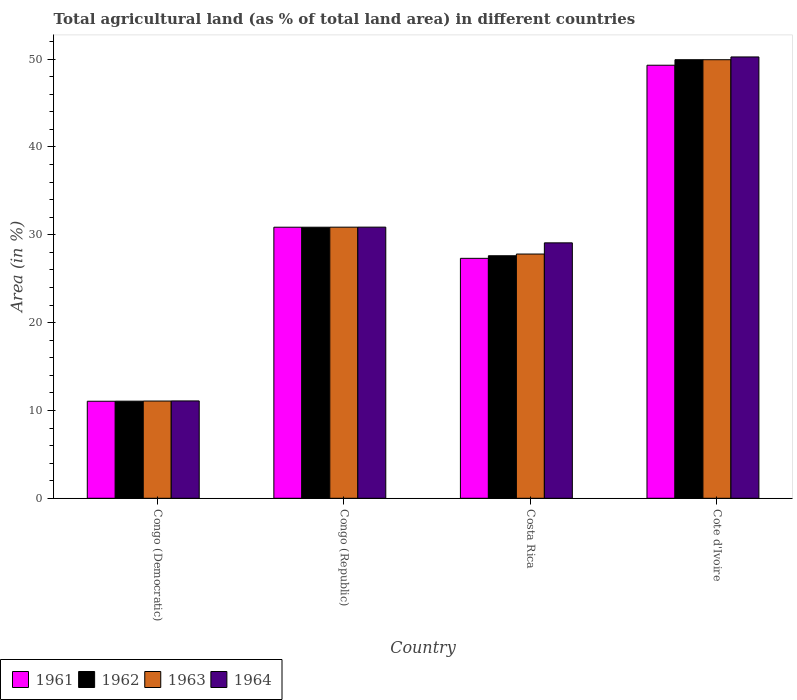How many different coloured bars are there?
Your answer should be compact. 4. How many groups of bars are there?
Your response must be concise. 4. Are the number of bars per tick equal to the number of legend labels?
Offer a terse response. Yes. Are the number of bars on each tick of the X-axis equal?
Keep it short and to the point. Yes. How many bars are there on the 3rd tick from the left?
Ensure brevity in your answer.  4. What is the label of the 4th group of bars from the left?
Offer a very short reply. Cote d'Ivoire. What is the percentage of agricultural land in 1963 in Congo (Democratic)?
Give a very brief answer. 11.07. Across all countries, what is the maximum percentage of agricultural land in 1963?
Make the answer very short. 49.94. Across all countries, what is the minimum percentage of agricultural land in 1963?
Provide a succinct answer. 11.07. In which country was the percentage of agricultural land in 1963 maximum?
Offer a terse response. Cote d'Ivoire. In which country was the percentage of agricultural land in 1964 minimum?
Make the answer very short. Congo (Democratic). What is the total percentage of agricultural land in 1962 in the graph?
Keep it short and to the point. 119.47. What is the difference between the percentage of agricultural land in 1961 in Costa Rica and that in Cote d'Ivoire?
Offer a terse response. -21.99. What is the difference between the percentage of agricultural land in 1961 in Congo (Democratic) and the percentage of agricultural land in 1964 in Congo (Republic)?
Your response must be concise. -19.82. What is the average percentage of agricultural land in 1963 per country?
Your answer should be compact. 29.92. What is the ratio of the percentage of agricultural land in 1962 in Congo (Democratic) to that in Costa Rica?
Ensure brevity in your answer.  0.4. What is the difference between the highest and the second highest percentage of agricultural land in 1964?
Offer a terse response. 21.17. What is the difference between the highest and the lowest percentage of agricultural land in 1962?
Make the answer very short. 38.88. Is it the case that in every country, the sum of the percentage of agricultural land in 1963 and percentage of agricultural land in 1964 is greater than the sum of percentage of agricultural land in 1961 and percentage of agricultural land in 1962?
Make the answer very short. No. What does the 2nd bar from the left in Congo (Republic) represents?
Give a very brief answer. 1962. What does the 3rd bar from the right in Congo (Democratic) represents?
Ensure brevity in your answer.  1962. Is it the case that in every country, the sum of the percentage of agricultural land in 1964 and percentage of agricultural land in 1961 is greater than the percentage of agricultural land in 1962?
Give a very brief answer. Yes. What is the difference between two consecutive major ticks on the Y-axis?
Your answer should be compact. 10. Does the graph contain any zero values?
Make the answer very short. No. Does the graph contain grids?
Make the answer very short. No. How many legend labels are there?
Keep it short and to the point. 4. How are the legend labels stacked?
Your response must be concise. Horizontal. What is the title of the graph?
Provide a short and direct response. Total agricultural land (as % of total land area) in different countries. What is the label or title of the Y-axis?
Give a very brief answer. Area (in %). What is the Area (in %) in 1961 in Congo (Democratic)?
Make the answer very short. 11.05. What is the Area (in %) of 1962 in Congo (Democratic)?
Provide a short and direct response. 11.06. What is the Area (in %) in 1963 in Congo (Democratic)?
Provide a short and direct response. 11.07. What is the Area (in %) in 1964 in Congo (Democratic)?
Offer a terse response. 11.08. What is the Area (in %) in 1961 in Congo (Republic)?
Make the answer very short. 30.86. What is the Area (in %) of 1962 in Congo (Republic)?
Offer a terse response. 30.86. What is the Area (in %) in 1963 in Congo (Republic)?
Keep it short and to the point. 30.87. What is the Area (in %) in 1964 in Congo (Republic)?
Provide a succinct answer. 30.87. What is the Area (in %) of 1961 in Costa Rica?
Offer a very short reply. 27.32. What is the Area (in %) of 1962 in Costa Rica?
Your answer should be compact. 27.61. What is the Area (in %) in 1963 in Costa Rica?
Make the answer very short. 27.81. What is the Area (in %) of 1964 in Costa Rica?
Offer a terse response. 29.08. What is the Area (in %) in 1961 in Cote d'Ivoire?
Your answer should be very brief. 49.31. What is the Area (in %) of 1962 in Cote d'Ivoire?
Offer a terse response. 49.94. What is the Area (in %) of 1963 in Cote d'Ivoire?
Your answer should be compact. 49.94. What is the Area (in %) in 1964 in Cote d'Ivoire?
Provide a succinct answer. 50.25. Across all countries, what is the maximum Area (in %) of 1961?
Keep it short and to the point. 49.31. Across all countries, what is the maximum Area (in %) of 1962?
Keep it short and to the point. 49.94. Across all countries, what is the maximum Area (in %) in 1963?
Keep it short and to the point. 49.94. Across all countries, what is the maximum Area (in %) of 1964?
Offer a terse response. 50.25. Across all countries, what is the minimum Area (in %) of 1961?
Keep it short and to the point. 11.05. Across all countries, what is the minimum Area (in %) in 1962?
Provide a succinct answer. 11.06. Across all countries, what is the minimum Area (in %) of 1963?
Your response must be concise. 11.07. Across all countries, what is the minimum Area (in %) in 1964?
Offer a very short reply. 11.08. What is the total Area (in %) of 1961 in the graph?
Ensure brevity in your answer.  118.54. What is the total Area (in %) of 1962 in the graph?
Offer a terse response. 119.47. What is the total Area (in %) in 1963 in the graph?
Offer a very short reply. 119.69. What is the total Area (in %) of 1964 in the graph?
Provide a short and direct response. 121.29. What is the difference between the Area (in %) of 1961 in Congo (Democratic) and that in Congo (Republic)?
Give a very brief answer. -19.81. What is the difference between the Area (in %) of 1962 in Congo (Democratic) and that in Congo (Republic)?
Make the answer very short. -19.81. What is the difference between the Area (in %) of 1963 in Congo (Democratic) and that in Congo (Republic)?
Your answer should be compact. -19.8. What is the difference between the Area (in %) in 1964 in Congo (Democratic) and that in Congo (Republic)?
Keep it short and to the point. -19.79. What is the difference between the Area (in %) of 1961 in Congo (Democratic) and that in Costa Rica?
Give a very brief answer. -16.27. What is the difference between the Area (in %) of 1962 in Congo (Democratic) and that in Costa Rica?
Give a very brief answer. -16.56. What is the difference between the Area (in %) in 1963 in Congo (Democratic) and that in Costa Rica?
Your response must be concise. -16.74. What is the difference between the Area (in %) of 1964 in Congo (Democratic) and that in Costa Rica?
Ensure brevity in your answer.  -18. What is the difference between the Area (in %) of 1961 in Congo (Democratic) and that in Cote d'Ivoire?
Provide a short and direct response. -38.26. What is the difference between the Area (in %) of 1962 in Congo (Democratic) and that in Cote d'Ivoire?
Ensure brevity in your answer.  -38.88. What is the difference between the Area (in %) in 1963 in Congo (Democratic) and that in Cote d'Ivoire?
Provide a succinct answer. -38.87. What is the difference between the Area (in %) of 1964 in Congo (Democratic) and that in Cote d'Ivoire?
Offer a very short reply. -39.17. What is the difference between the Area (in %) of 1961 in Congo (Republic) and that in Costa Rica?
Make the answer very short. 3.54. What is the difference between the Area (in %) of 1962 in Congo (Republic) and that in Costa Rica?
Make the answer very short. 3.25. What is the difference between the Area (in %) in 1963 in Congo (Republic) and that in Costa Rica?
Make the answer very short. 3.06. What is the difference between the Area (in %) in 1964 in Congo (Republic) and that in Costa Rica?
Your answer should be compact. 1.79. What is the difference between the Area (in %) in 1961 in Congo (Republic) and that in Cote d'Ivoire?
Your answer should be very brief. -18.44. What is the difference between the Area (in %) in 1962 in Congo (Republic) and that in Cote d'Ivoire?
Offer a very short reply. -19.07. What is the difference between the Area (in %) of 1963 in Congo (Republic) and that in Cote d'Ivoire?
Ensure brevity in your answer.  -19.07. What is the difference between the Area (in %) of 1964 in Congo (Republic) and that in Cote d'Ivoire?
Ensure brevity in your answer.  -19.38. What is the difference between the Area (in %) of 1961 in Costa Rica and that in Cote d'Ivoire?
Offer a very short reply. -21.99. What is the difference between the Area (in %) in 1962 in Costa Rica and that in Cote d'Ivoire?
Offer a very short reply. -22.32. What is the difference between the Area (in %) of 1963 in Costa Rica and that in Cote d'Ivoire?
Provide a short and direct response. -22.13. What is the difference between the Area (in %) of 1964 in Costa Rica and that in Cote d'Ivoire?
Provide a succinct answer. -21.17. What is the difference between the Area (in %) in 1961 in Congo (Democratic) and the Area (in %) in 1962 in Congo (Republic)?
Keep it short and to the point. -19.81. What is the difference between the Area (in %) of 1961 in Congo (Democratic) and the Area (in %) of 1963 in Congo (Republic)?
Your response must be concise. -19.82. What is the difference between the Area (in %) in 1961 in Congo (Democratic) and the Area (in %) in 1964 in Congo (Republic)?
Provide a succinct answer. -19.82. What is the difference between the Area (in %) of 1962 in Congo (Democratic) and the Area (in %) of 1963 in Congo (Republic)?
Give a very brief answer. -19.81. What is the difference between the Area (in %) in 1962 in Congo (Democratic) and the Area (in %) in 1964 in Congo (Republic)?
Provide a short and direct response. -19.81. What is the difference between the Area (in %) in 1963 in Congo (Democratic) and the Area (in %) in 1964 in Congo (Republic)?
Offer a very short reply. -19.8. What is the difference between the Area (in %) of 1961 in Congo (Democratic) and the Area (in %) of 1962 in Costa Rica?
Offer a terse response. -16.57. What is the difference between the Area (in %) of 1961 in Congo (Democratic) and the Area (in %) of 1963 in Costa Rica?
Give a very brief answer. -16.76. What is the difference between the Area (in %) in 1961 in Congo (Democratic) and the Area (in %) in 1964 in Costa Rica?
Your answer should be very brief. -18.03. What is the difference between the Area (in %) in 1962 in Congo (Democratic) and the Area (in %) in 1963 in Costa Rica?
Offer a terse response. -16.75. What is the difference between the Area (in %) of 1962 in Congo (Democratic) and the Area (in %) of 1964 in Costa Rica?
Give a very brief answer. -18.02. What is the difference between the Area (in %) of 1963 in Congo (Democratic) and the Area (in %) of 1964 in Costa Rica?
Provide a short and direct response. -18.01. What is the difference between the Area (in %) of 1961 in Congo (Democratic) and the Area (in %) of 1962 in Cote d'Ivoire?
Your response must be concise. -38.89. What is the difference between the Area (in %) in 1961 in Congo (Democratic) and the Area (in %) in 1963 in Cote d'Ivoire?
Make the answer very short. -38.89. What is the difference between the Area (in %) of 1961 in Congo (Democratic) and the Area (in %) of 1964 in Cote d'Ivoire?
Provide a succinct answer. -39.2. What is the difference between the Area (in %) in 1962 in Congo (Democratic) and the Area (in %) in 1963 in Cote d'Ivoire?
Your answer should be compact. -38.88. What is the difference between the Area (in %) in 1962 in Congo (Democratic) and the Area (in %) in 1964 in Cote d'Ivoire?
Ensure brevity in your answer.  -39.19. What is the difference between the Area (in %) of 1963 in Congo (Democratic) and the Area (in %) of 1964 in Cote d'Ivoire?
Offer a very short reply. -39.18. What is the difference between the Area (in %) in 1961 in Congo (Republic) and the Area (in %) in 1962 in Costa Rica?
Keep it short and to the point. 3.25. What is the difference between the Area (in %) in 1961 in Congo (Republic) and the Area (in %) in 1963 in Costa Rica?
Ensure brevity in your answer.  3.05. What is the difference between the Area (in %) of 1961 in Congo (Republic) and the Area (in %) of 1964 in Costa Rica?
Your answer should be very brief. 1.78. What is the difference between the Area (in %) in 1962 in Congo (Republic) and the Area (in %) in 1963 in Costa Rica?
Your response must be concise. 3.05. What is the difference between the Area (in %) of 1962 in Congo (Republic) and the Area (in %) of 1964 in Costa Rica?
Keep it short and to the point. 1.78. What is the difference between the Area (in %) of 1963 in Congo (Republic) and the Area (in %) of 1964 in Costa Rica?
Keep it short and to the point. 1.79. What is the difference between the Area (in %) of 1961 in Congo (Republic) and the Area (in %) of 1962 in Cote d'Ivoire?
Your response must be concise. -19.07. What is the difference between the Area (in %) of 1961 in Congo (Republic) and the Area (in %) of 1963 in Cote d'Ivoire?
Ensure brevity in your answer.  -19.07. What is the difference between the Area (in %) of 1961 in Congo (Republic) and the Area (in %) of 1964 in Cote d'Ivoire?
Offer a very short reply. -19.39. What is the difference between the Area (in %) in 1962 in Congo (Republic) and the Area (in %) in 1963 in Cote d'Ivoire?
Your answer should be very brief. -19.07. What is the difference between the Area (in %) of 1962 in Congo (Republic) and the Area (in %) of 1964 in Cote d'Ivoire?
Keep it short and to the point. -19.39. What is the difference between the Area (in %) in 1963 in Congo (Republic) and the Area (in %) in 1964 in Cote d'Ivoire?
Provide a succinct answer. -19.38. What is the difference between the Area (in %) of 1961 in Costa Rica and the Area (in %) of 1962 in Cote d'Ivoire?
Your response must be concise. -22.62. What is the difference between the Area (in %) of 1961 in Costa Rica and the Area (in %) of 1963 in Cote d'Ivoire?
Offer a very short reply. -22.62. What is the difference between the Area (in %) of 1961 in Costa Rica and the Area (in %) of 1964 in Cote d'Ivoire?
Provide a short and direct response. -22.93. What is the difference between the Area (in %) in 1962 in Costa Rica and the Area (in %) in 1963 in Cote d'Ivoire?
Your response must be concise. -22.32. What is the difference between the Area (in %) in 1962 in Costa Rica and the Area (in %) in 1964 in Cote d'Ivoire?
Your answer should be very brief. -22.64. What is the difference between the Area (in %) of 1963 in Costa Rica and the Area (in %) of 1964 in Cote d'Ivoire?
Make the answer very short. -22.44. What is the average Area (in %) of 1961 per country?
Your response must be concise. 29.64. What is the average Area (in %) of 1962 per country?
Keep it short and to the point. 29.87. What is the average Area (in %) in 1963 per country?
Make the answer very short. 29.92. What is the average Area (in %) in 1964 per country?
Provide a succinct answer. 30.32. What is the difference between the Area (in %) of 1961 and Area (in %) of 1962 in Congo (Democratic)?
Offer a terse response. -0.01. What is the difference between the Area (in %) of 1961 and Area (in %) of 1963 in Congo (Democratic)?
Provide a short and direct response. -0.02. What is the difference between the Area (in %) in 1961 and Area (in %) in 1964 in Congo (Democratic)?
Offer a terse response. -0.04. What is the difference between the Area (in %) of 1962 and Area (in %) of 1963 in Congo (Democratic)?
Keep it short and to the point. -0.01. What is the difference between the Area (in %) of 1962 and Area (in %) of 1964 in Congo (Democratic)?
Your answer should be very brief. -0.03. What is the difference between the Area (in %) of 1963 and Area (in %) of 1964 in Congo (Democratic)?
Provide a succinct answer. -0.01. What is the difference between the Area (in %) in 1961 and Area (in %) in 1963 in Congo (Republic)?
Keep it short and to the point. -0.01. What is the difference between the Area (in %) of 1961 and Area (in %) of 1964 in Congo (Republic)?
Your response must be concise. -0.01. What is the difference between the Area (in %) in 1962 and Area (in %) in 1963 in Congo (Republic)?
Ensure brevity in your answer.  -0.01. What is the difference between the Area (in %) of 1962 and Area (in %) of 1964 in Congo (Republic)?
Ensure brevity in your answer.  -0.01. What is the difference between the Area (in %) of 1963 and Area (in %) of 1964 in Congo (Republic)?
Your answer should be compact. -0. What is the difference between the Area (in %) of 1961 and Area (in %) of 1962 in Costa Rica?
Give a very brief answer. -0.29. What is the difference between the Area (in %) in 1961 and Area (in %) in 1963 in Costa Rica?
Ensure brevity in your answer.  -0.49. What is the difference between the Area (in %) of 1961 and Area (in %) of 1964 in Costa Rica?
Your response must be concise. -1.76. What is the difference between the Area (in %) of 1962 and Area (in %) of 1963 in Costa Rica?
Provide a short and direct response. -0.2. What is the difference between the Area (in %) of 1962 and Area (in %) of 1964 in Costa Rica?
Offer a terse response. -1.47. What is the difference between the Area (in %) of 1963 and Area (in %) of 1964 in Costa Rica?
Your answer should be compact. -1.27. What is the difference between the Area (in %) of 1961 and Area (in %) of 1962 in Cote d'Ivoire?
Offer a terse response. -0.63. What is the difference between the Area (in %) in 1961 and Area (in %) in 1963 in Cote d'Ivoire?
Your response must be concise. -0.63. What is the difference between the Area (in %) in 1961 and Area (in %) in 1964 in Cote d'Ivoire?
Provide a short and direct response. -0.94. What is the difference between the Area (in %) of 1962 and Area (in %) of 1963 in Cote d'Ivoire?
Provide a short and direct response. 0. What is the difference between the Area (in %) of 1962 and Area (in %) of 1964 in Cote d'Ivoire?
Give a very brief answer. -0.31. What is the difference between the Area (in %) of 1963 and Area (in %) of 1964 in Cote d'Ivoire?
Offer a terse response. -0.31. What is the ratio of the Area (in %) in 1961 in Congo (Democratic) to that in Congo (Republic)?
Make the answer very short. 0.36. What is the ratio of the Area (in %) of 1962 in Congo (Democratic) to that in Congo (Republic)?
Give a very brief answer. 0.36. What is the ratio of the Area (in %) in 1963 in Congo (Democratic) to that in Congo (Republic)?
Make the answer very short. 0.36. What is the ratio of the Area (in %) in 1964 in Congo (Democratic) to that in Congo (Republic)?
Offer a terse response. 0.36. What is the ratio of the Area (in %) in 1961 in Congo (Democratic) to that in Costa Rica?
Your answer should be very brief. 0.4. What is the ratio of the Area (in %) in 1962 in Congo (Democratic) to that in Costa Rica?
Make the answer very short. 0.4. What is the ratio of the Area (in %) of 1963 in Congo (Democratic) to that in Costa Rica?
Keep it short and to the point. 0.4. What is the ratio of the Area (in %) in 1964 in Congo (Democratic) to that in Costa Rica?
Make the answer very short. 0.38. What is the ratio of the Area (in %) in 1961 in Congo (Democratic) to that in Cote d'Ivoire?
Ensure brevity in your answer.  0.22. What is the ratio of the Area (in %) in 1962 in Congo (Democratic) to that in Cote d'Ivoire?
Your response must be concise. 0.22. What is the ratio of the Area (in %) in 1963 in Congo (Democratic) to that in Cote d'Ivoire?
Make the answer very short. 0.22. What is the ratio of the Area (in %) in 1964 in Congo (Democratic) to that in Cote d'Ivoire?
Give a very brief answer. 0.22. What is the ratio of the Area (in %) of 1961 in Congo (Republic) to that in Costa Rica?
Your answer should be compact. 1.13. What is the ratio of the Area (in %) in 1962 in Congo (Republic) to that in Costa Rica?
Give a very brief answer. 1.12. What is the ratio of the Area (in %) in 1963 in Congo (Republic) to that in Costa Rica?
Offer a very short reply. 1.11. What is the ratio of the Area (in %) of 1964 in Congo (Republic) to that in Costa Rica?
Keep it short and to the point. 1.06. What is the ratio of the Area (in %) of 1961 in Congo (Republic) to that in Cote d'Ivoire?
Keep it short and to the point. 0.63. What is the ratio of the Area (in %) of 1962 in Congo (Republic) to that in Cote d'Ivoire?
Your answer should be compact. 0.62. What is the ratio of the Area (in %) of 1963 in Congo (Republic) to that in Cote d'Ivoire?
Make the answer very short. 0.62. What is the ratio of the Area (in %) of 1964 in Congo (Republic) to that in Cote d'Ivoire?
Your answer should be very brief. 0.61. What is the ratio of the Area (in %) of 1961 in Costa Rica to that in Cote d'Ivoire?
Offer a terse response. 0.55. What is the ratio of the Area (in %) of 1962 in Costa Rica to that in Cote d'Ivoire?
Offer a terse response. 0.55. What is the ratio of the Area (in %) in 1963 in Costa Rica to that in Cote d'Ivoire?
Ensure brevity in your answer.  0.56. What is the ratio of the Area (in %) in 1964 in Costa Rica to that in Cote d'Ivoire?
Offer a very short reply. 0.58. What is the difference between the highest and the second highest Area (in %) in 1961?
Offer a terse response. 18.44. What is the difference between the highest and the second highest Area (in %) in 1962?
Offer a terse response. 19.07. What is the difference between the highest and the second highest Area (in %) of 1963?
Your answer should be very brief. 19.07. What is the difference between the highest and the second highest Area (in %) of 1964?
Your answer should be compact. 19.38. What is the difference between the highest and the lowest Area (in %) in 1961?
Give a very brief answer. 38.26. What is the difference between the highest and the lowest Area (in %) of 1962?
Make the answer very short. 38.88. What is the difference between the highest and the lowest Area (in %) of 1963?
Offer a terse response. 38.87. What is the difference between the highest and the lowest Area (in %) in 1964?
Your answer should be very brief. 39.17. 